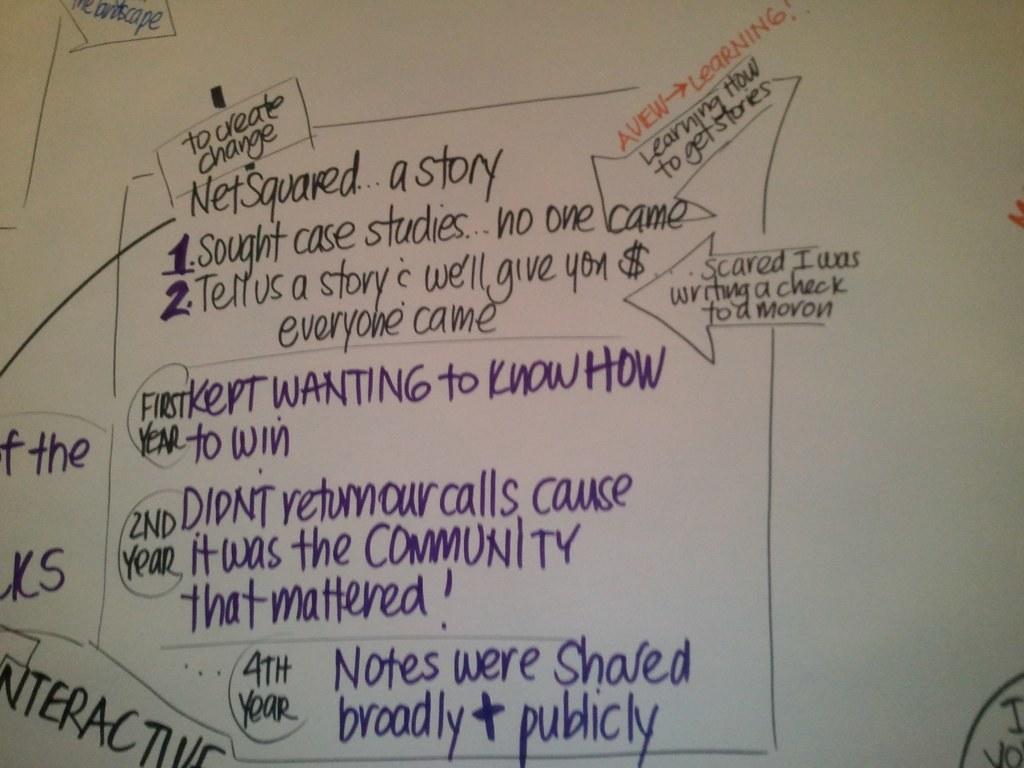Kept wanting to know how to what?
Provide a short and direct response. Win. How were notes shared?
Provide a short and direct response. Broadly & publicly. 